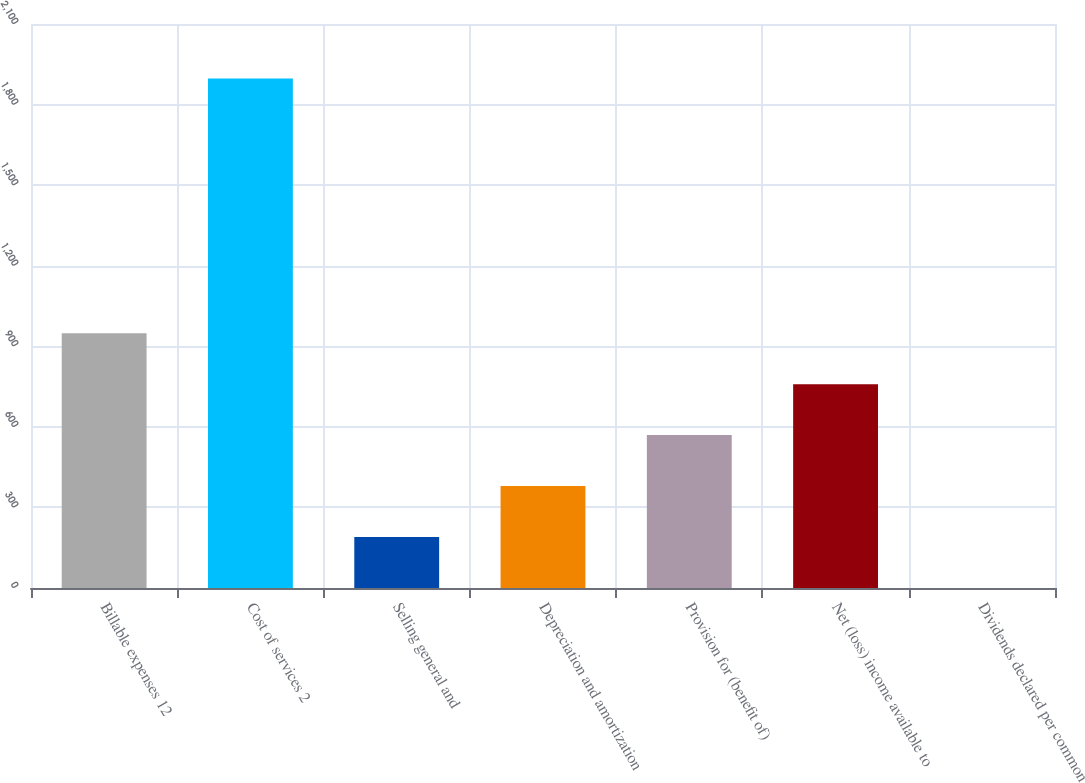Convert chart. <chart><loc_0><loc_0><loc_500><loc_500><bar_chart><fcel>Billable expenses 12<fcel>Cost of services 2<fcel>Selling general and<fcel>Depreciation and amortization<fcel>Provision for (benefit of)<fcel>Net (loss) income available to<fcel>Dividends declared per common<nl><fcel>948.78<fcel>1897.4<fcel>189.9<fcel>379.62<fcel>569.34<fcel>759.06<fcel>0.18<nl></chart> 